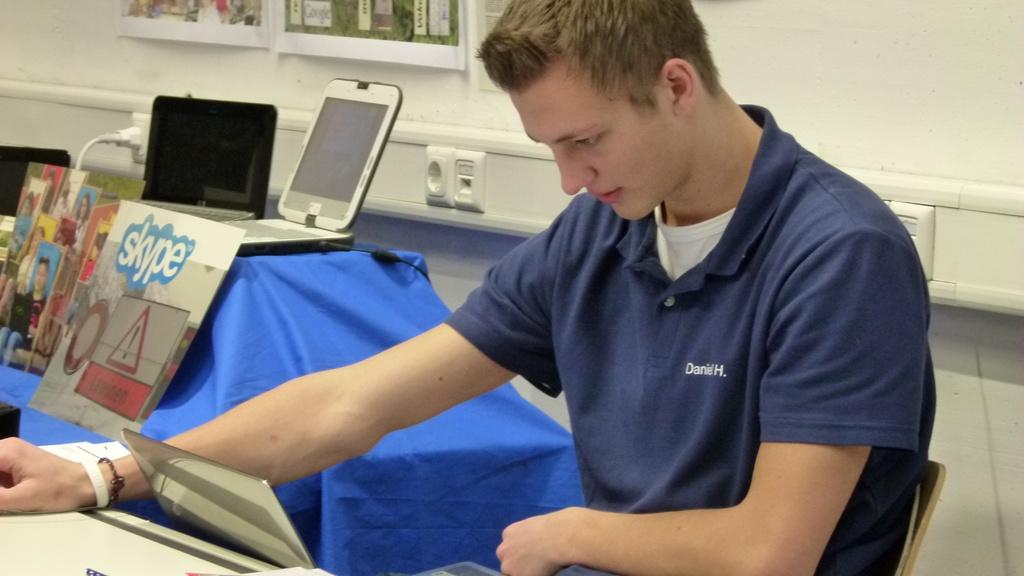<image>
Write a terse but informative summary of the picture. A guy wearing a shirt that says Daniel H. on it as he looks down at a screen. 